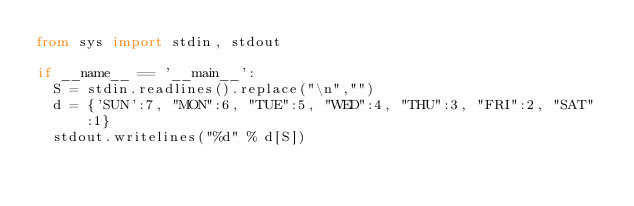Convert code to text. <code><loc_0><loc_0><loc_500><loc_500><_Python_>from sys import stdin, stdout

if __name__ == '__main__':
  S = stdin.readlines().replace("\n","")
  d = {'SUN':7, "MON":6, "TUE":5, "WED":4, "THU":3, "FRI":2, "SAT":1}
  stdout.writelines("%d" % d[S])</code> 